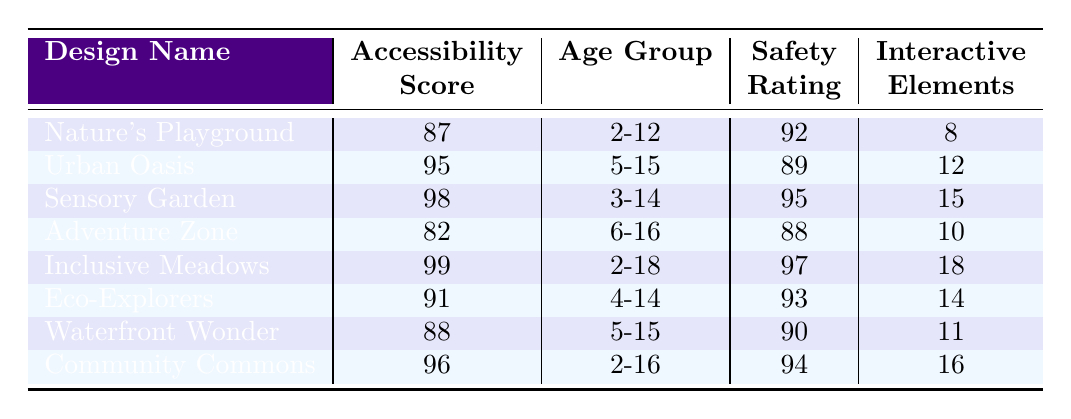What is the accessibility score of "Sensory Garden"? The table lists "Sensory Garden" with an accessibility score of 98 in the accessibility score column.
Answer: 98 Which playground design has the lowest safety rating? By comparing the safety ratings in the table, "Adventure Zone" has the lowest rating at 88.
Answer: Adventure Zone How many interactive elements does "Inclusive Meadows" have? The table shows "Inclusive Meadows" has 18 interactive elements listed in the interactive elements column.
Answer: 18 What is the difference in accessibility scores between "Nature's Playground" and "Urban Oasis"? The accessibility score for "Nature's Playground" is 87, and for "Urban Oasis," it is 95. The difference is 95 - 87 = 8.
Answer: 8 Is the safety rating of "Waterfront Wonder" above 89? According to the table, "Waterfront Wonder" has a safety rating of 90, which is indeed above 89.
Answer: Yes What is the average accessibility score of all playground designs? To find the average, sum the accessibility scores (87 + 95 + 98 + 82 + 99 + 91 + 88 + 96 = 1000) and divide by the number of designs (8): 1000 / 8 = 125.
Answer: 125 Which playground design has the most interactive elements and what is its accessibility score? "Inclusive Meadows" has the most interactive elements, totaling 18, and its accessibility score is 99 according to the table.
Answer: Inclusive Meadows, 99 How many designs have an accessibility score of 90 or above? Counting the designs with scores from the table: "Urban Oasis," "Sensory Garden," "Inclusive Meadows," "Eco-Explorers," and "Community Commons," we have 5 designs that meet this criterion.
Answer: 5 What playground design has an accessibility score closest to the median of all scores? Organizing the scores (82, 87, 88, 91, 95, 96, 98, 99) gives a median of 92.5 (average of 91 and 95). "Eco-Explorers" has a score of 91, which is closest to the median.
Answer: Eco-Explorers Is there a playground design that caters to children aged 2-18? Yes, "Inclusive Meadows" is designed for children aged 2-18, as stated in the age group column.
Answer: Yes 